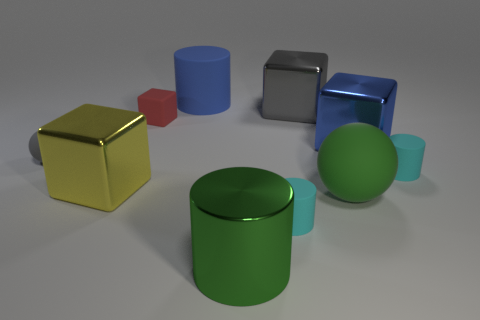Is there a big metallic cube that has the same color as the tiny rubber block?
Offer a terse response. No. How many things are metal cylinders or large things that are behind the red object?
Provide a short and direct response. 3. Are there more tiny red objects than large yellow matte blocks?
Give a very brief answer. Yes. What is the size of the metallic thing that is the same color as the small sphere?
Give a very brief answer. Large. Is there a cyan block made of the same material as the red cube?
Offer a terse response. No. What is the shape of the thing that is in front of the big green ball and behind the green metal cylinder?
Your response must be concise. Cylinder. What number of other things are there of the same shape as the red matte thing?
Your answer should be compact. 3. How big is the green shiny object?
Make the answer very short. Large. How many things are either green metallic cylinders or big blue metal objects?
Ensure brevity in your answer.  2. There is a sphere on the right side of the small gray rubber sphere; how big is it?
Make the answer very short. Large. 